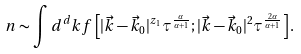<formula> <loc_0><loc_0><loc_500><loc_500>n \sim \int d ^ { d } k f \left [ | { \vec { k } } - { \vec { k } } _ { 0 } | ^ { z _ { 1 } } \tau ^ { \frac { \alpha } { \alpha + 1 } } ; | { \vec { k } } - { \vec { k } } _ { 0 } | ^ { 2 } \tau ^ { \frac { 2 \alpha } { \alpha + 1 } } \right ] .</formula> 